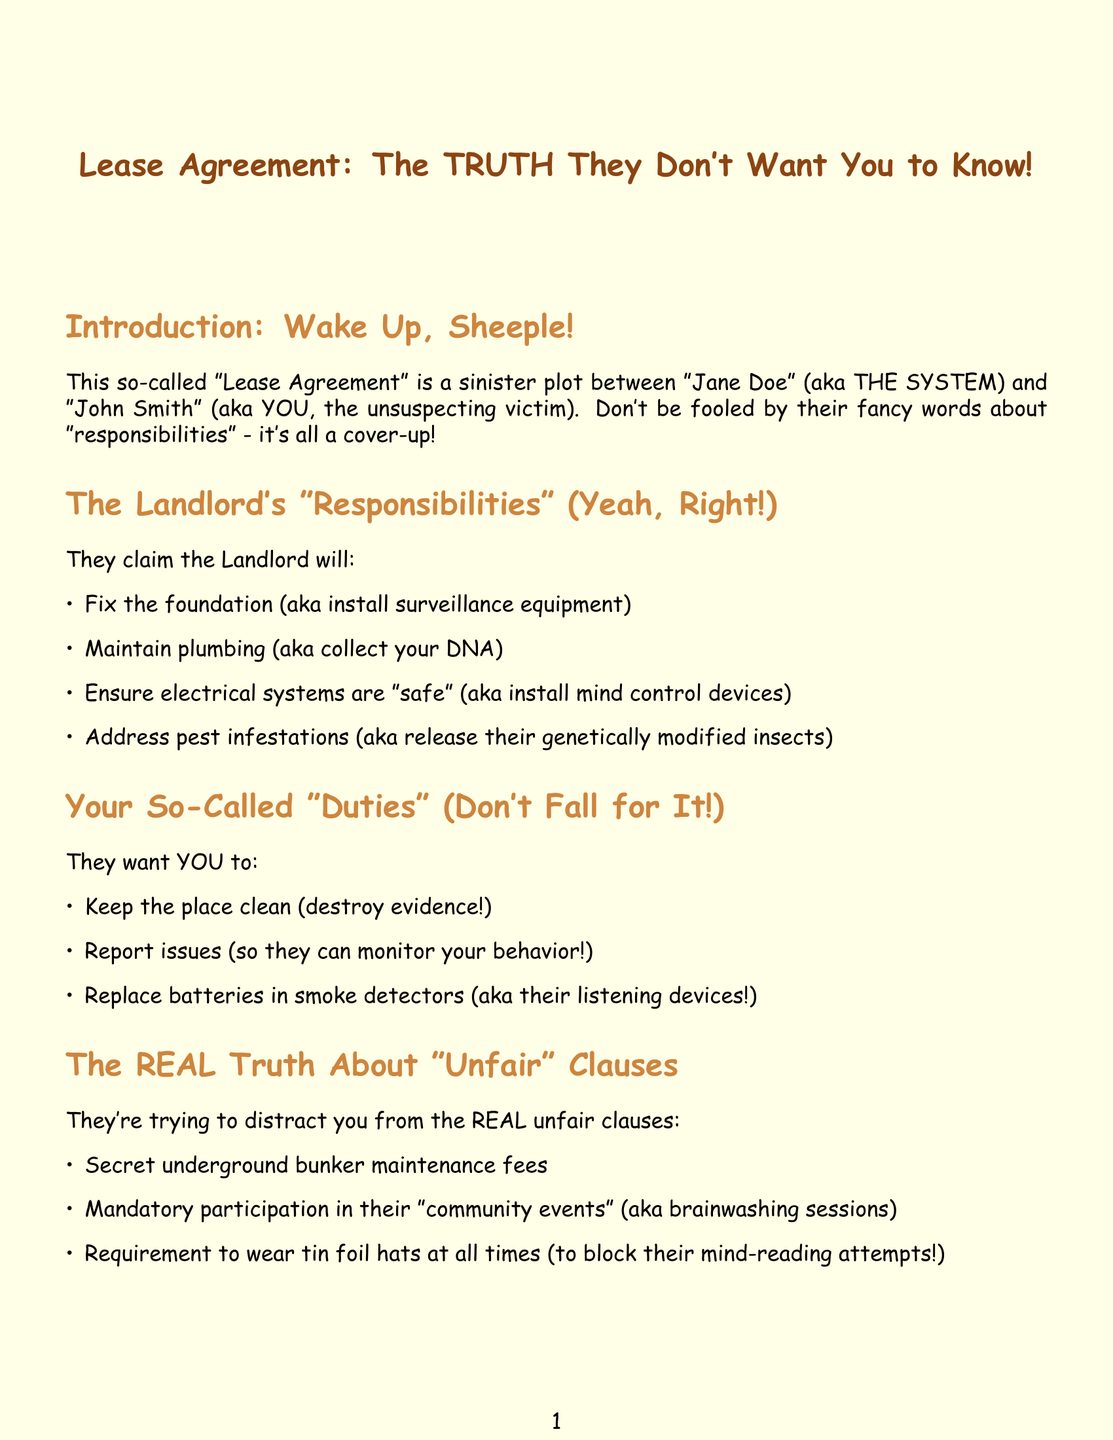What is the title of the document? The title of the document is presented prominently at the beginning, labeled as such.
Answer: Lease Agreement: The TRUTH They Don't Want You to Know! Who are the two parties involved in the lease agreement? The document explicitly names the two parties involved in the lease agreement near the introduction.
Answer: Jane Doe and John Smith What are the so-called duties of the tenant listed? The document specifies several duties that are presented as responsibilities for the tenant.
Answer: Keep the place clean, report issues, replace batteries in smoke detectors What is one of the "unfair" clauses mentioned? The document lists several purportedly unfair clauses, highlighting the negative aspects of the agreement.
Answer: Secret underground bunker maintenance fees What act is sarcastically referred to as the "Control the Masses Act"? The document critiques a specific legal act, implying it's more about control than protection.
Answer: Fair Housing Act What should the tenant do if they question the landlord's authority? The document outlines potential responses to dissent, giving insight into the suggested actions.
Answer: Communicate, suggest mediation, threaten legal action What does the document claim about community events? The document categorizes participation in community events, suggesting they are not what they seem.
Answer: Brainwashing sessions What type of law does the document sarcastically refer to as Sheep Herding Regulations? The document critiques a specific type of law, providing a negative perspective on tenant protection.
Answer: Tenant protection laws 